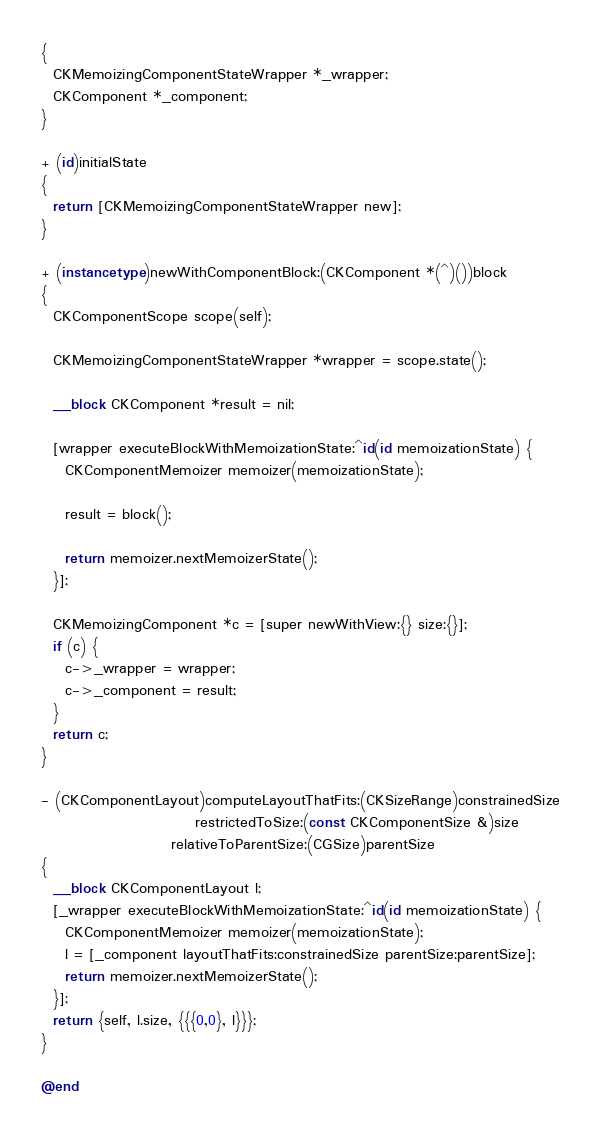Convert code to text. <code><loc_0><loc_0><loc_500><loc_500><_ObjectiveC_>{
  CKMemoizingComponentStateWrapper *_wrapper;
  CKComponent *_component;
}

+ (id)initialState
{
  return [CKMemoizingComponentStateWrapper new];
}

+ (instancetype)newWithComponentBlock:(CKComponent *(^)())block
{
  CKComponentScope scope(self);

  CKMemoizingComponentStateWrapper *wrapper = scope.state();

  __block CKComponent *result = nil;

  [wrapper executeBlockWithMemoizationState:^id(id memoizationState) {
    CKComponentMemoizer memoizer(memoizationState);

    result = block();

    return memoizer.nextMemoizerState();
  }];

  CKMemoizingComponent *c = [super newWithView:{} size:{}];
  if (c) {
    c->_wrapper = wrapper;
    c->_component = result;
  }
  return c;
}

- (CKComponentLayout)computeLayoutThatFits:(CKSizeRange)constrainedSize
                          restrictedToSize:(const CKComponentSize &)size
                      relativeToParentSize:(CGSize)parentSize
{
  __block CKComponentLayout l;
  [_wrapper executeBlockWithMemoizationState:^id(id memoizationState) {
    CKComponentMemoizer memoizer(memoizationState);
    l = [_component layoutThatFits:constrainedSize parentSize:parentSize];
    return memoizer.nextMemoizerState();
  }];
  return {self, l.size, {{{0,0}, l}}};
}

@end
</code> 